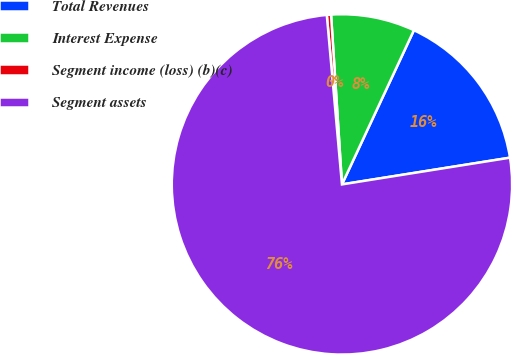Convert chart to OTSL. <chart><loc_0><loc_0><loc_500><loc_500><pie_chart><fcel>Total Revenues<fcel>Interest Expense<fcel>Segment income (loss) (b)(c)<fcel>Segment assets<nl><fcel>15.54%<fcel>7.97%<fcel>0.4%<fcel>76.09%<nl></chart> 